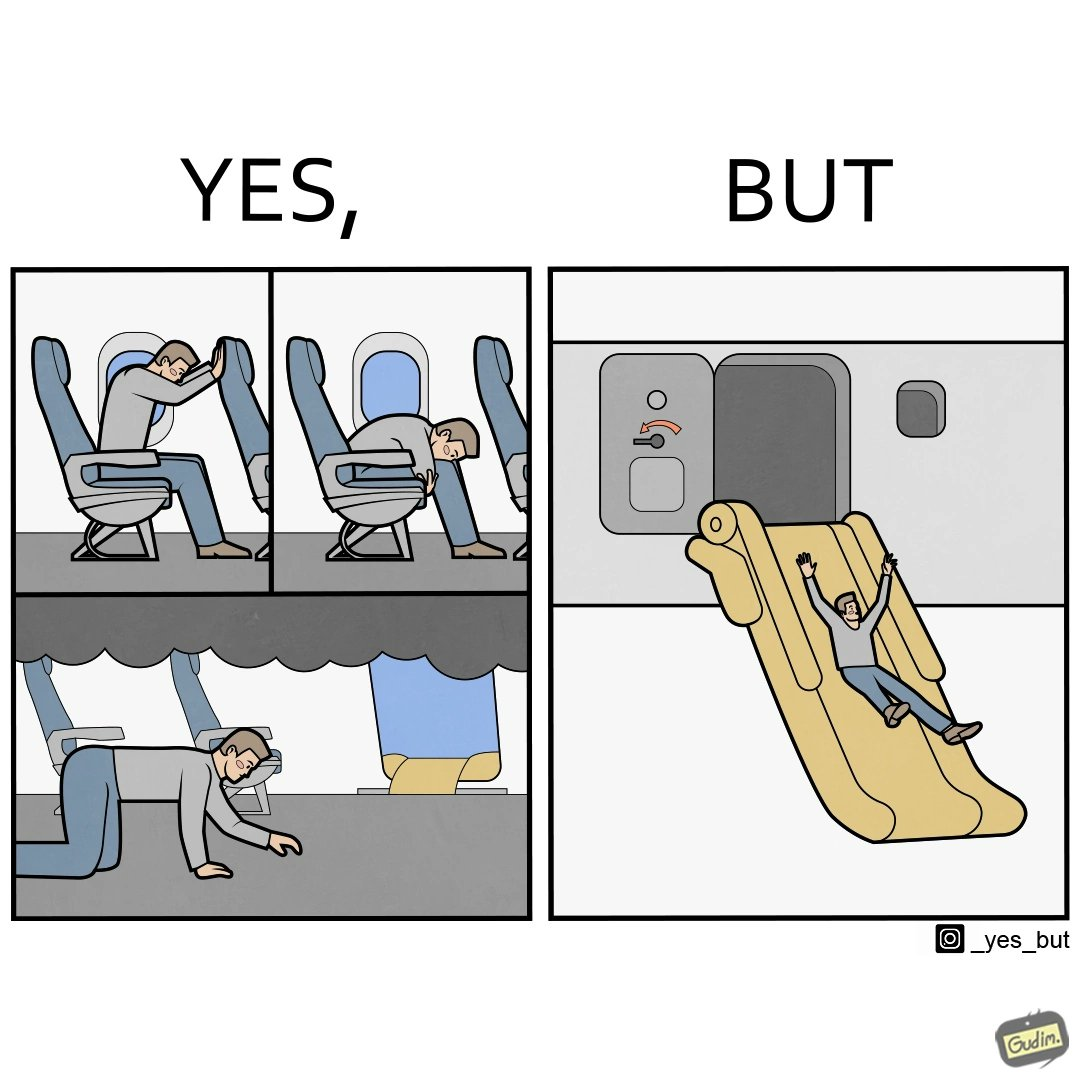What is the satirical meaning behind this image? These images are funny since it shows how we are taught emergency procedures to follow in case of an accident while in an airplane but how none of them work if the plane is still in air 